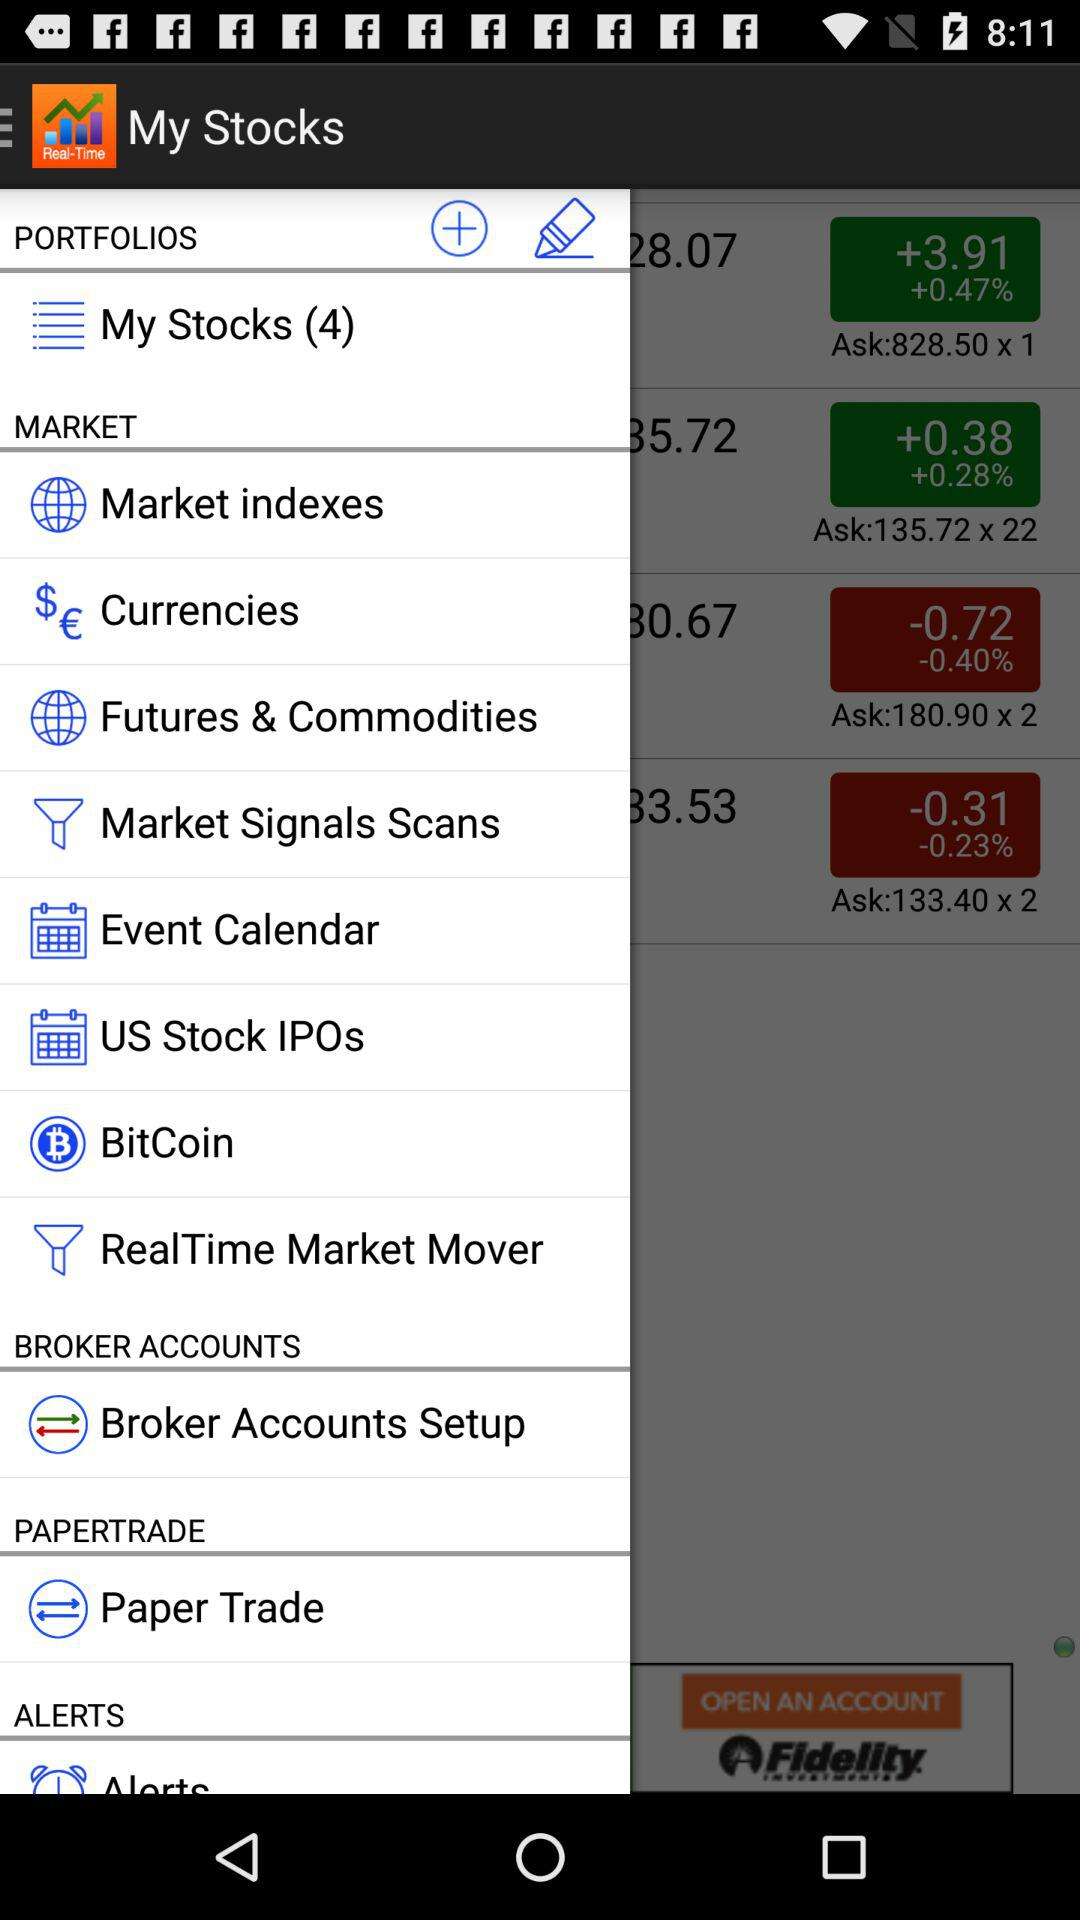How many stocks are there? There are 4 stocks. 